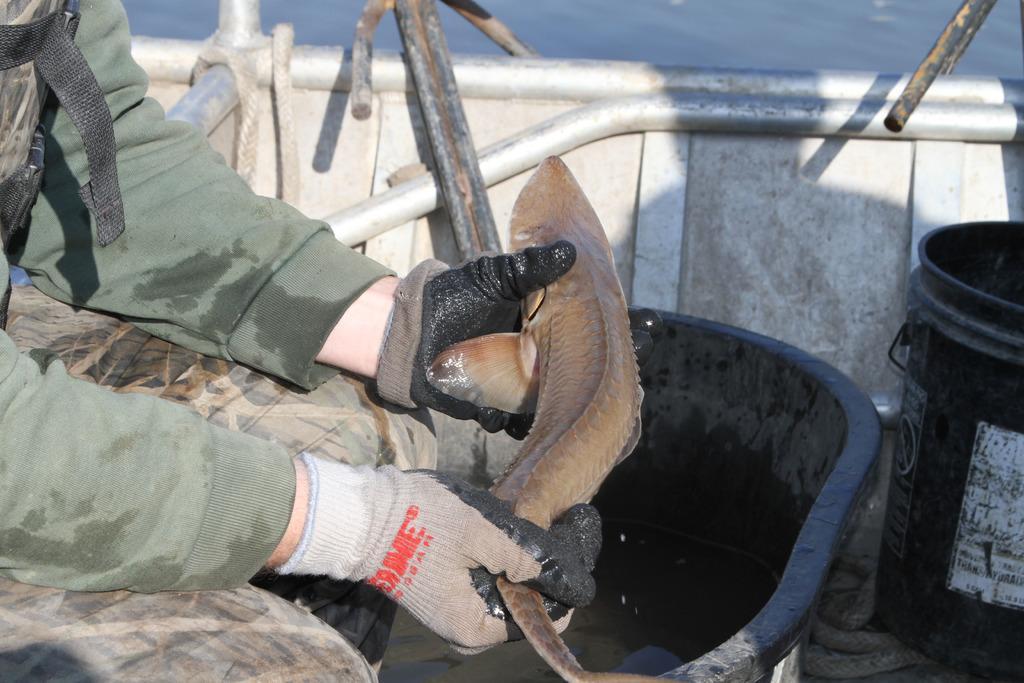Please provide a concise description of this image. In this picture we can see a person wore gloves and holding a fish, tub, bucket and in the background we can see water. 